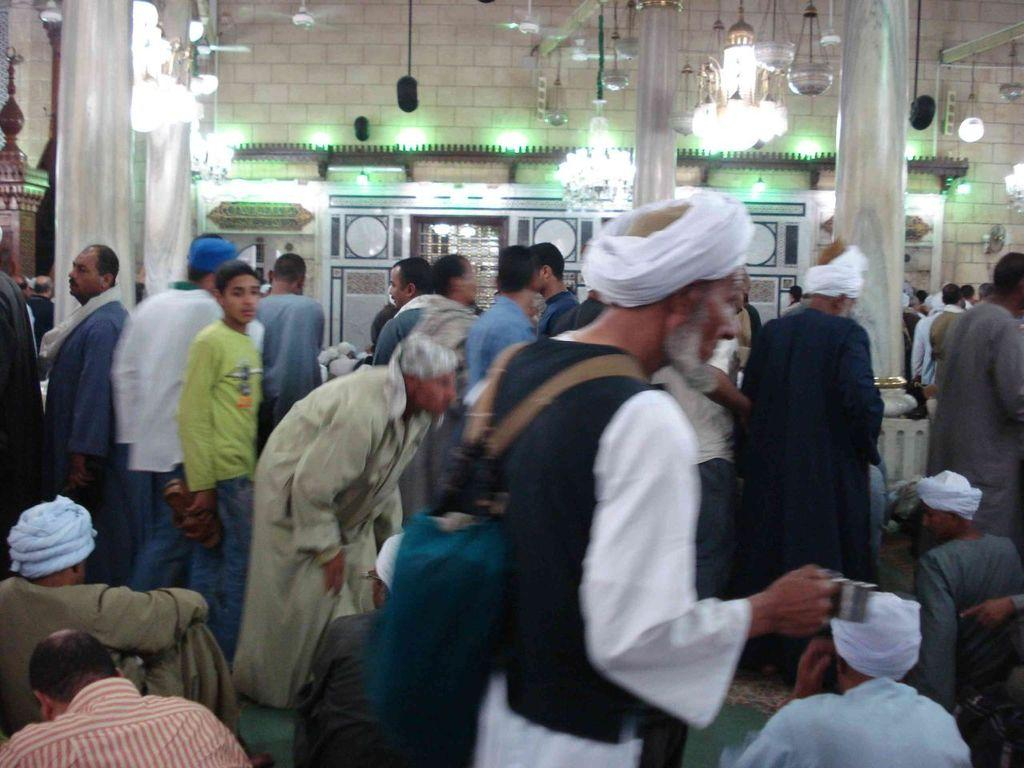What can be seen in the image involving multiple individuals? There is a group of people in the image. What architectural feature is present in the image? There is a wall in the image. What structural elements support the wall? There are pillars in the image. What can be seen providing illumination in the image? There are lights in the image. How many lizards are crawling on the ground in the image? There are no lizards present in the image. What type of smile can be seen on the wall in the image? There is no smile depicted on the wall in the image. 